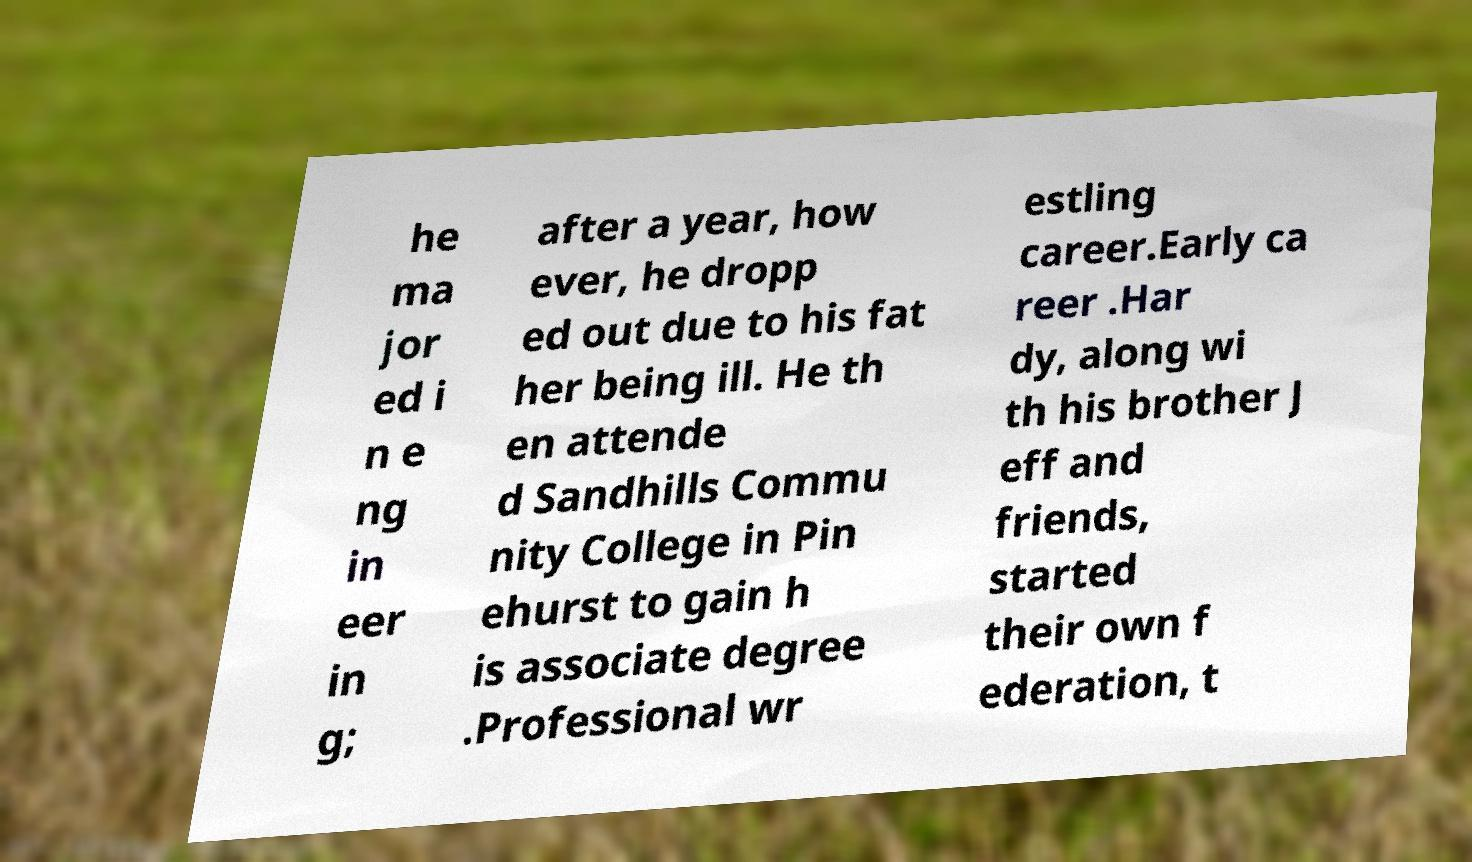Please read and relay the text visible in this image. What does it say? he ma jor ed i n e ng in eer in g; after a year, how ever, he dropp ed out due to his fat her being ill. He th en attende d Sandhills Commu nity College in Pin ehurst to gain h is associate degree .Professional wr estling career.Early ca reer .Har dy, along wi th his brother J eff and friends, started their own f ederation, t 